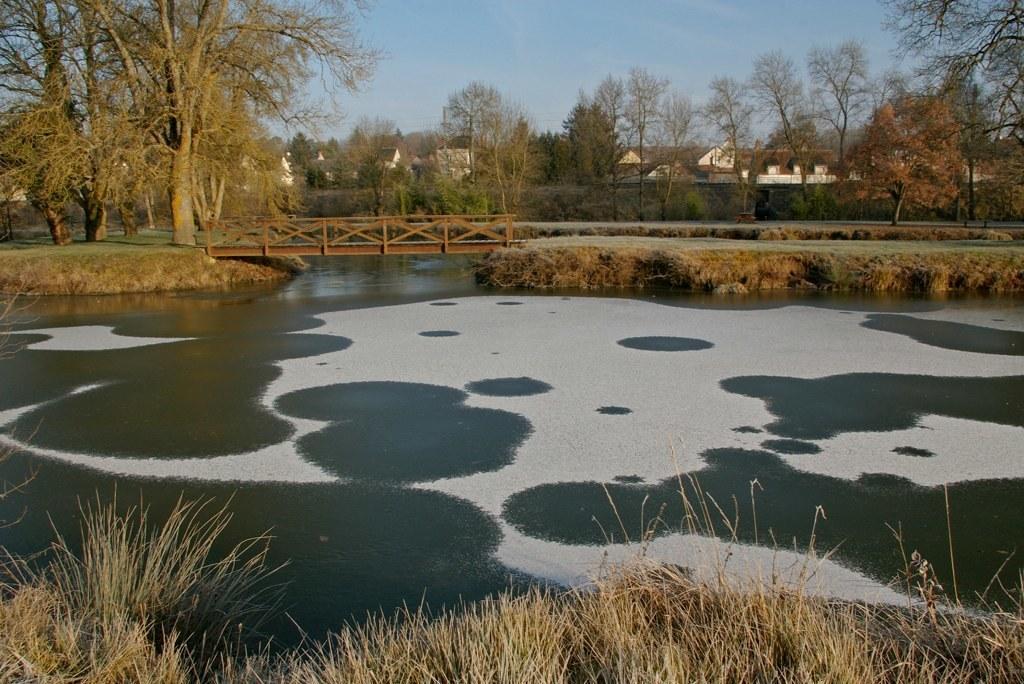Could you give a brief overview of what you see in this image? Here we can see water, grass, and a bridge. In the background there are trees, houses, and sky. 